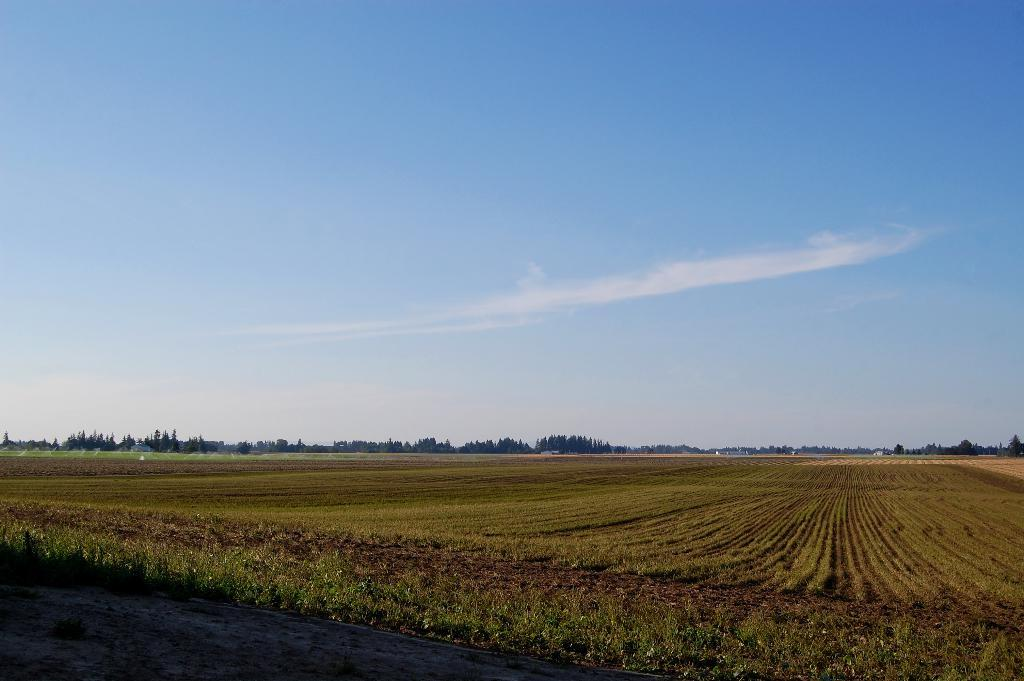What is located in the front of the image? There is a road in the front of the image. What can be seen in the background of the image? There are farms and trees in the background of the image. What is visible above the farms and trees? The sky is visible in the image. What can be observed in the sky? Clouds are present in the sky. What type of sofa can be seen in the image? There is no sofa present in the image. What is the condition of the road in the image? The condition of the road cannot be determined from the image alone, as it only shows the road's presence and not its condition. 